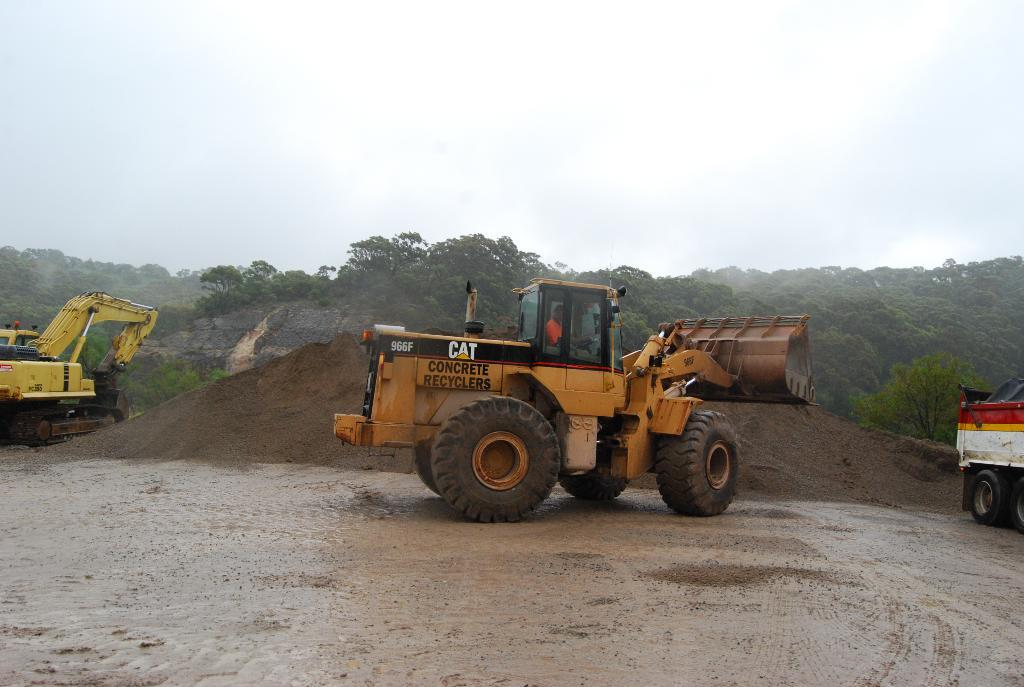How many bulldozers are in the image? There are two bulldozers in the image. What other vehicle can be seen in the image? There is a truck in the image. What is the condition of the water in the image? The water is muddy in the image. What type of terrain is present in the image? Sand is present in the image. What can be seen in the background of the image? There are trees and the sky visible in the background of the image. How many rings are being exchanged between the bulldozers in the image? There are no rings present in the image, as it features construction vehicles and equipment. What type of debt is being discussed by the truck and bulldozers in the image? There is no discussion of debt in the image, as it focuses on construction vehicles and equipment. 